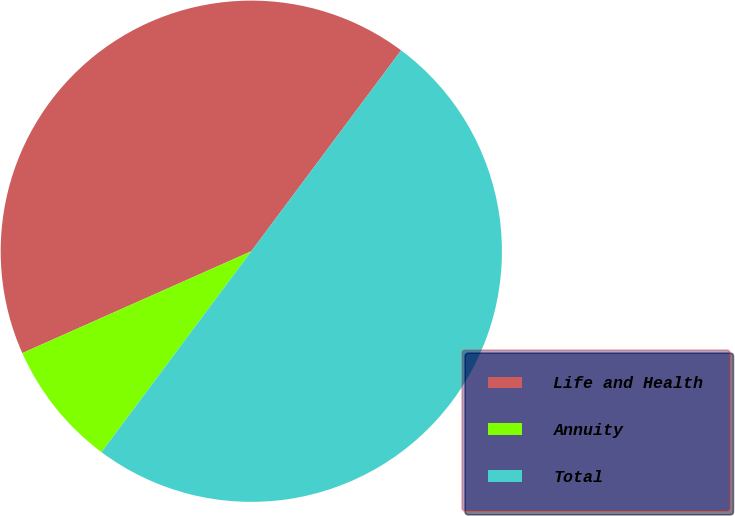Convert chart to OTSL. <chart><loc_0><loc_0><loc_500><loc_500><pie_chart><fcel>Life and Health<fcel>Annuity<fcel>Total<nl><fcel>41.86%<fcel>8.14%<fcel>50.0%<nl></chart> 